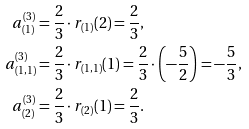<formula> <loc_0><loc_0><loc_500><loc_500>a _ { ( 1 ) } ^ { ( 3 ) } & = \frac { 2 } { 3 } \cdot r _ { ( 1 ) } ( 2 ) = \frac { 2 } { 3 } , \\ a _ { ( 1 , 1 ) } ^ { ( 3 ) } & = \frac { 2 } { 3 } \cdot r _ { ( 1 , 1 ) } ( 1 ) = \frac { 2 } { 3 } \cdot \left ( - \frac { 5 } { 2 } \right ) = - \frac { 5 } { 3 } , \\ a _ { ( 2 ) } ^ { ( 3 ) } & = \frac { 2 } { 3 } \cdot r _ { ( 2 ) } ( 1 ) = \frac { 2 } { 3 } .</formula> 